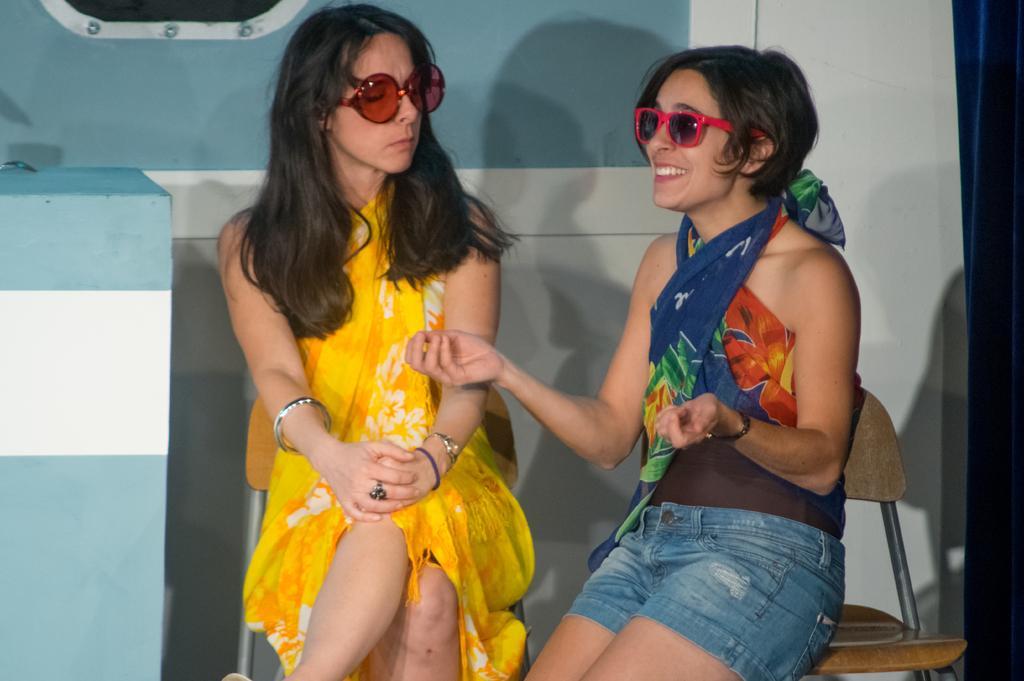In one or two sentences, can you explain what this image depicts? On the left side, there is a woman in a yellow colored dress, sitting and there is an object. On the right side, there is another woman, smiling and sitting on another chair. In the background, there is a wall. 